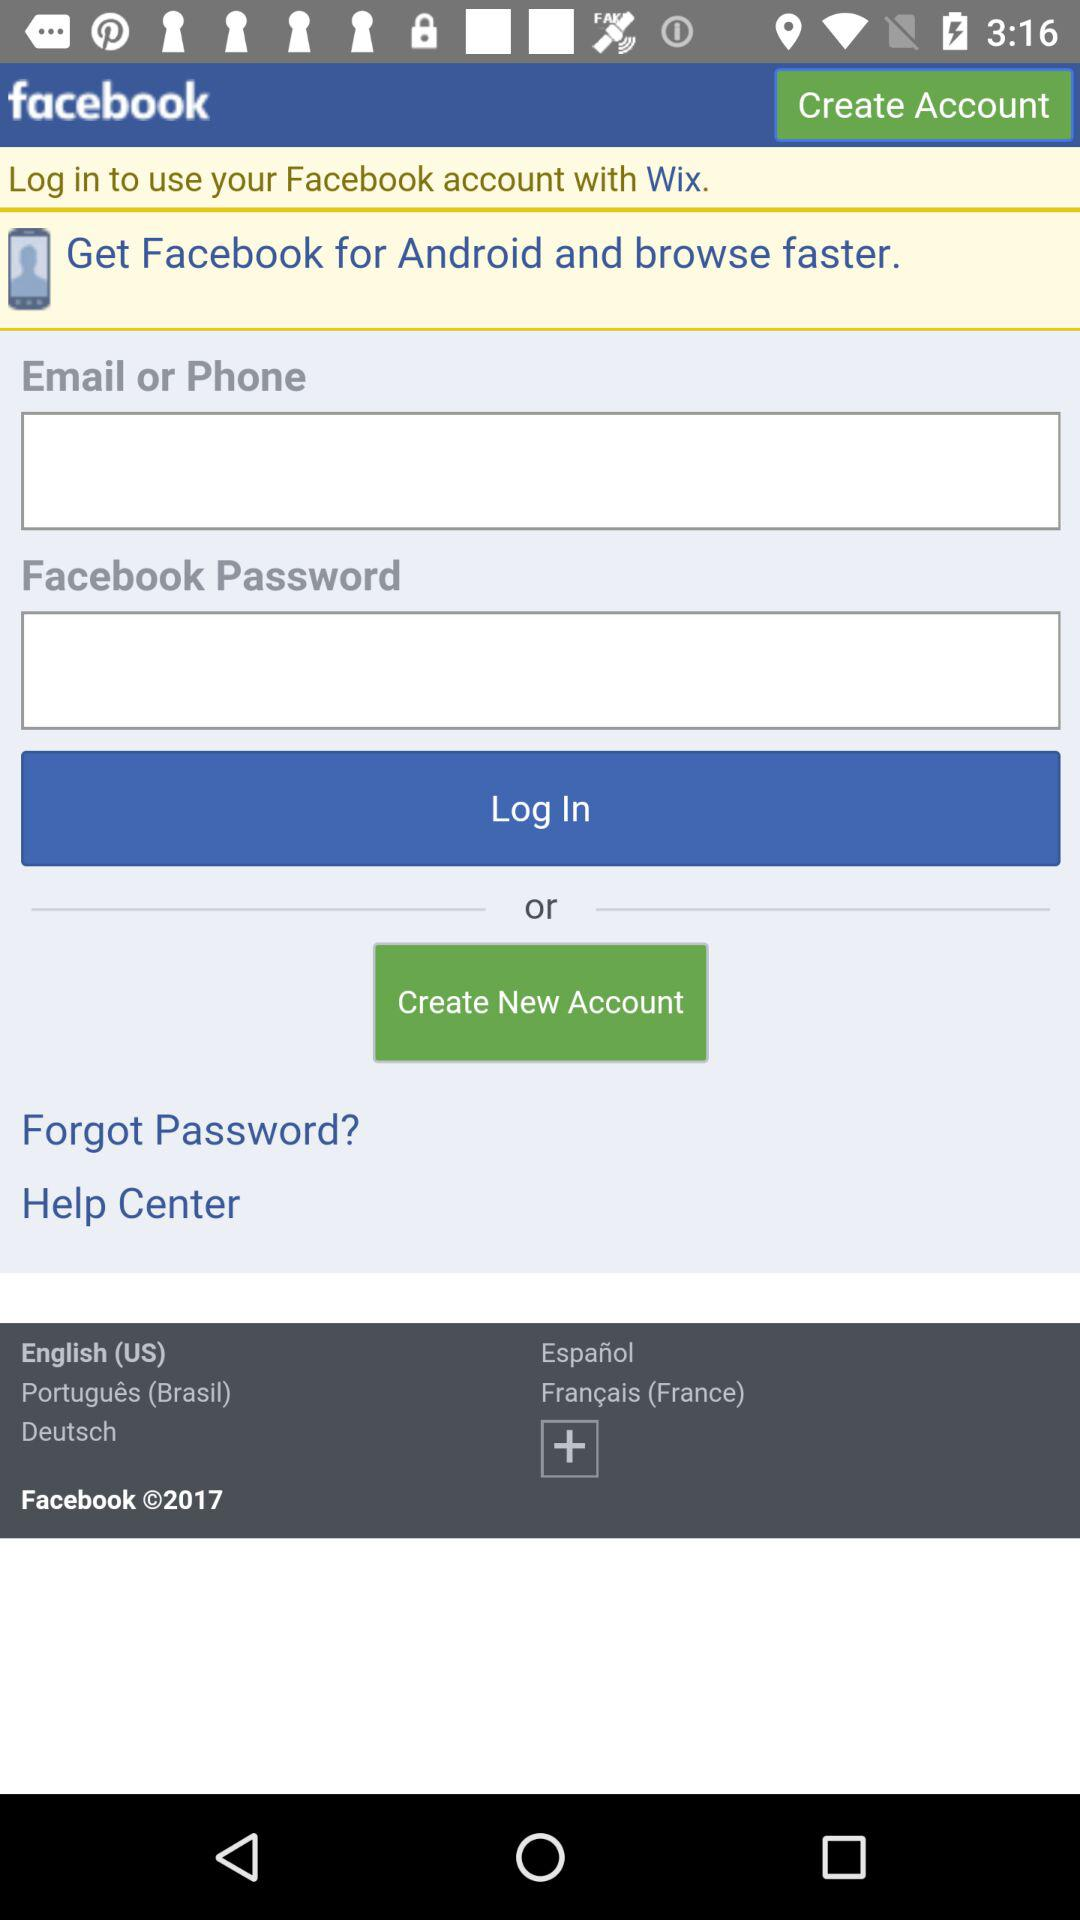Which version of facebook is this?
When the provided information is insufficient, respond with <no answer>. <no answer> 